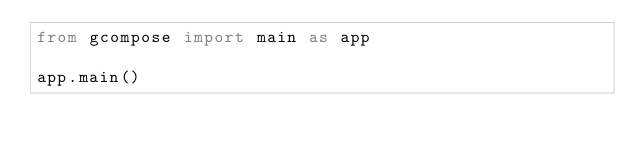Convert code to text. <code><loc_0><loc_0><loc_500><loc_500><_Python_>from gcompose import main as app

app.main()
</code> 